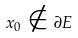<formula> <loc_0><loc_0><loc_500><loc_500>x _ { 0 } \notin \partial E</formula> 